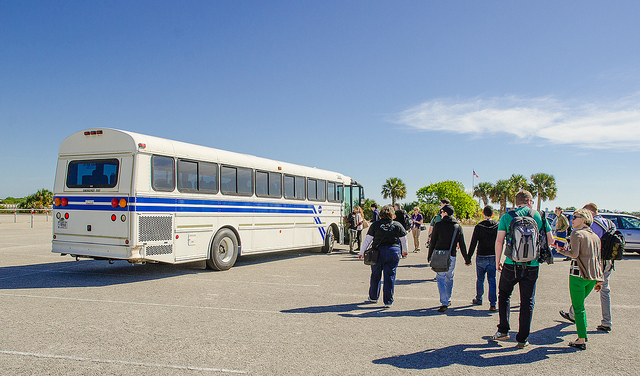<image>What objects are leaning against the bus? I don't know what objects are leaning against the bus. It could be people or a suitcase. What animal is in the lot? I am not sure what animal is in the lot. It has seen humans, dogs or birds. What objects are leaning against the bus? I don't know what objects are leaning against the bus. It can be seen that there are people and a suitcase. What animal is in the lot? I am not sure what animal is in the lot. It can be a dog, humans, human, or a bird. 